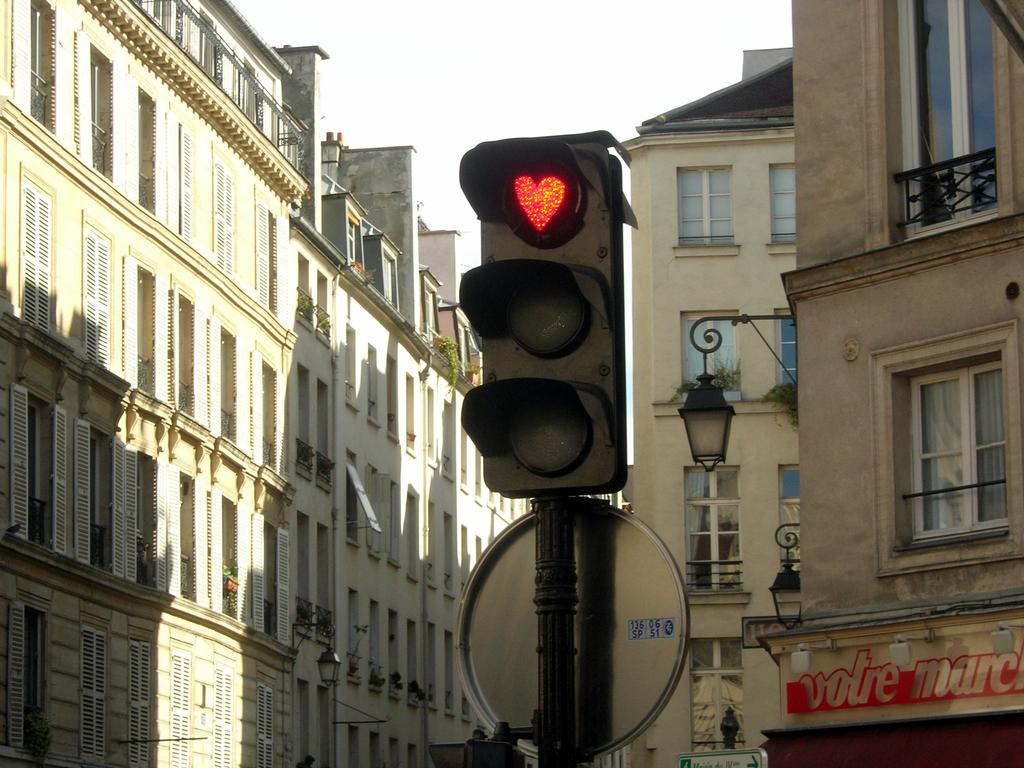What is the main object in the image? There is a traffic signal in the image. How is the traffic signal attached to the pole? The traffic signal is attached to a pole. What type of structures can be seen in the image? There are buildings with windows in the image. What type of lighting is visible in the image? Lamps are visible in the image. What kind of signage is present in the image? There is a name board in the image. What type of punishment is being handed out by the traffic signal in the image? There is no punishment being handed out by the traffic signal in the image; it is a device used for regulating traffic. 